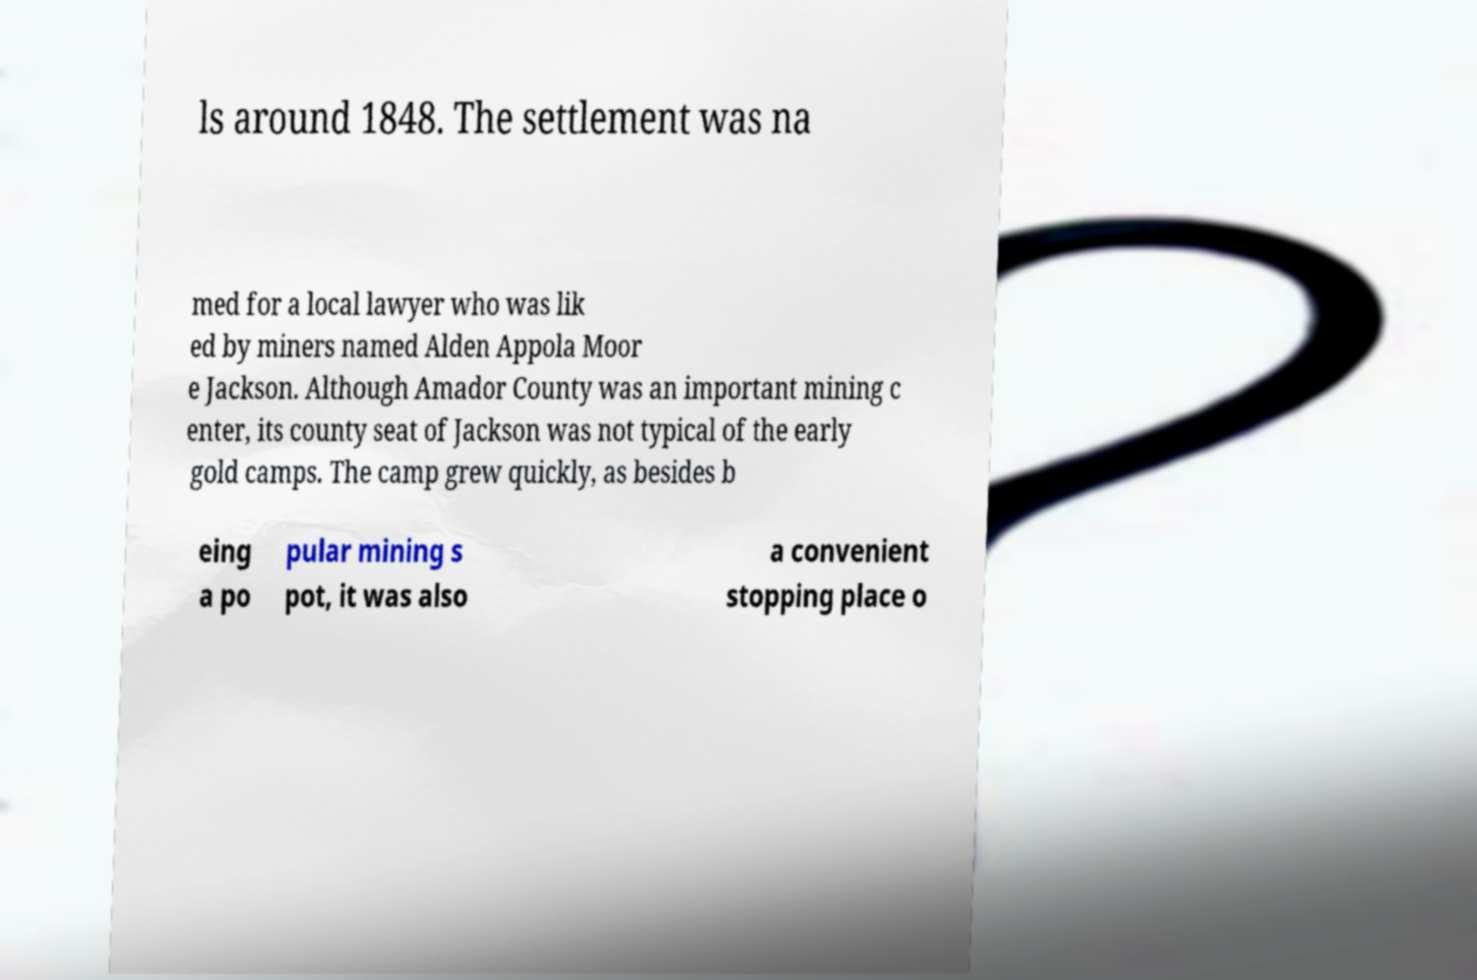What messages or text are displayed in this image? I need them in a readable, typed format. ls around 1848. The settlement was na med for a local lawyer who was lik ed by miners named Alden Appola Moor e Jackson. Although Amador County was an important mining c enter, its county seat of Jackson was not typical of the early gold camps. The camp grew quickly, as besides b eing a po pular mining s pot, it was also a convenient stopping place o 